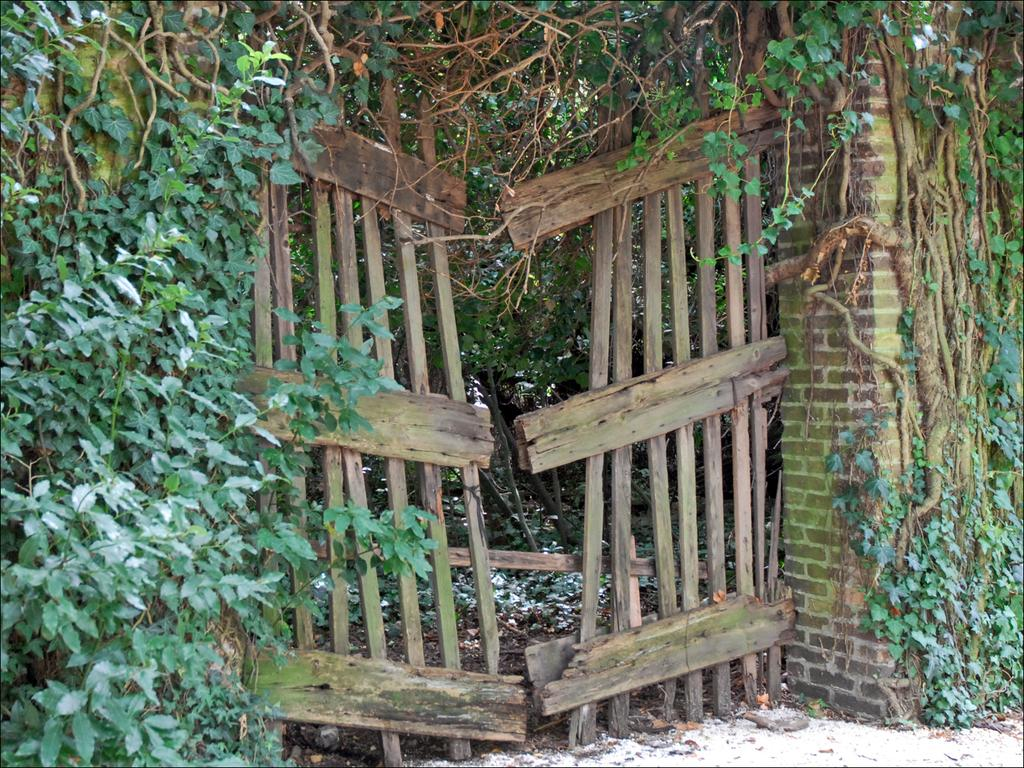What type of vegetation can be seen in the image? There are trees in the image. What is the color of the trees? The trees are green in color. What type of material is used to construct the wall in the image? The wall in the image is made of bricks. What is the gate made of in the image? The gate in the image is made of wooden logs. Can you see any dogs in the image that are made of flesh? There are no dogs present in the image, and the concept of a dog made of flesh is not relevant to the image. 